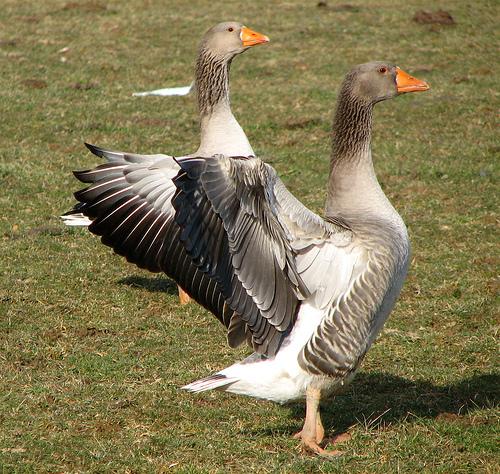How many different kinds of animals are in this picture?
Write a very short answer. 1. How many birds are there?
Give a very brief answer. 2. Are the ducks looking at each other?
Concise answer only. No. Which way are the birds facing?
Quick response, please. Right. Are the birds flying?
Keep it brief. No. 